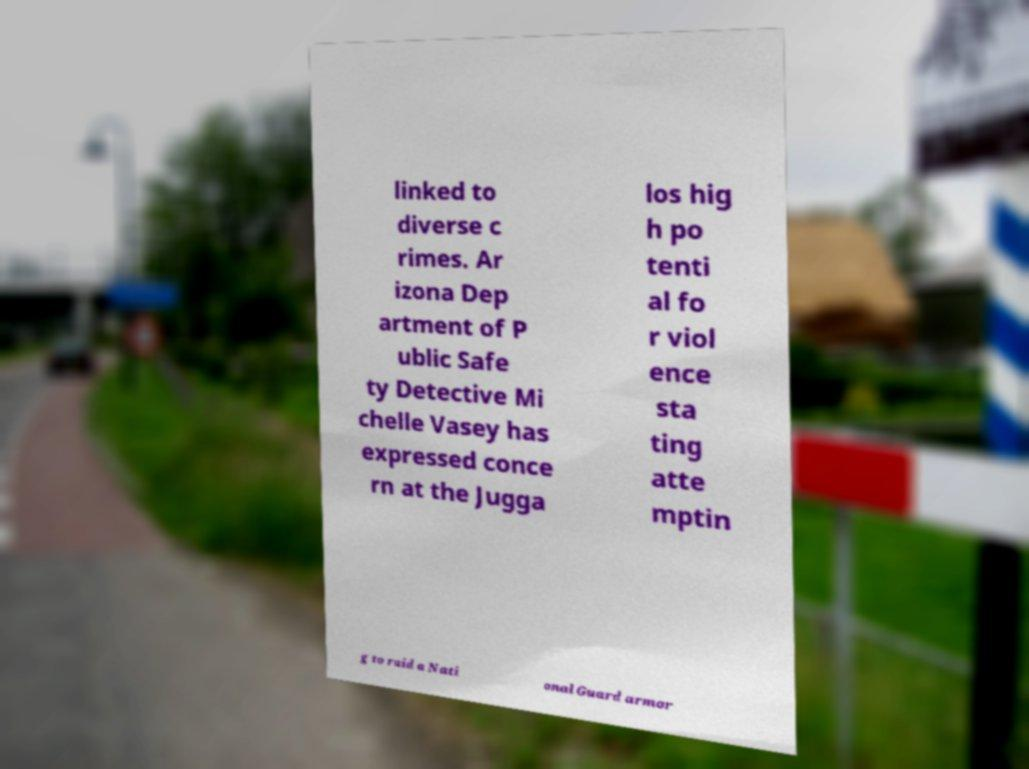Can you read and provide the text displayed in the image?This photo seems to have some interesting text. Can you extract and type it out for me? linked to diverse c rimes. Ar izona Dep artment of P ublic Safe ty Detective Mi chelle Vasey has expressed conce rn at the Jugga los hig h po tenti al fo r viol ence sta ting atte mptin g to raid a Nati onal Guard armor 